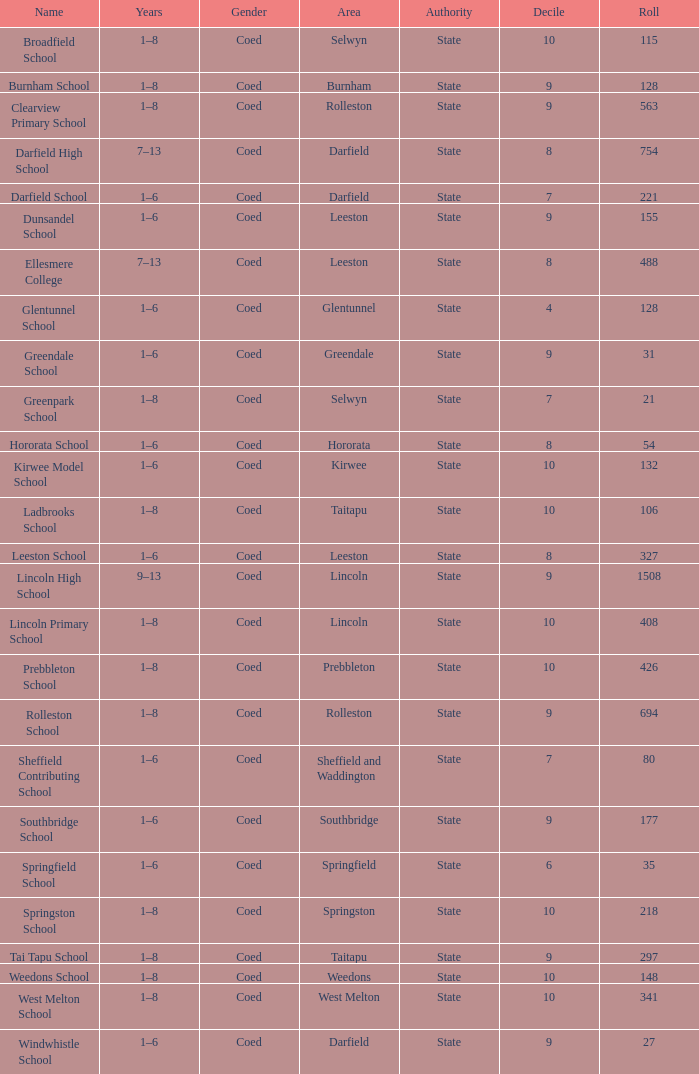Which area has a Decile of 9, and a Roll of 31? Greendale. 